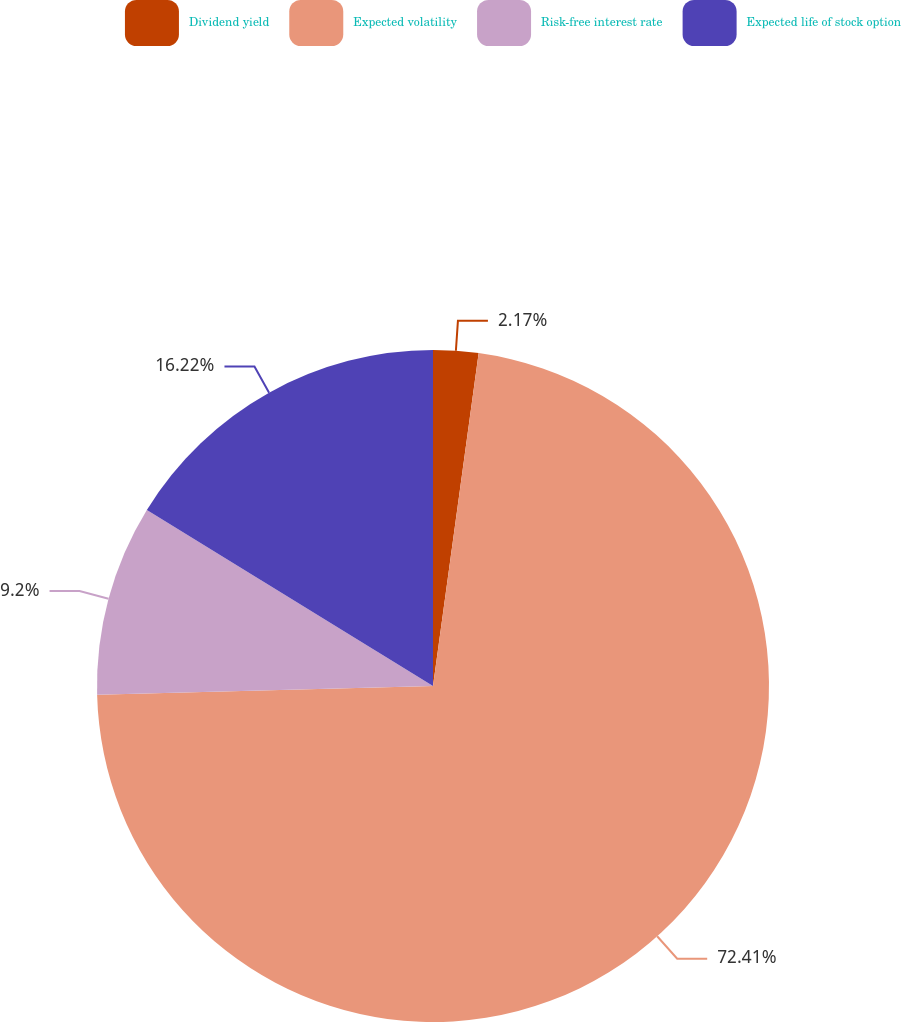<chart> <loc_0><loc_0><loc_500><loc_500><pie_chart><fcel>Dividend yield<fcel>Expected volatility<fcel>Risk-free interest rate<fcel>Expected life of stock option<nl><fcel>2.17%<fcel>72.41%<fcel>9.2%<fcel>16.22%<nl></chart> 